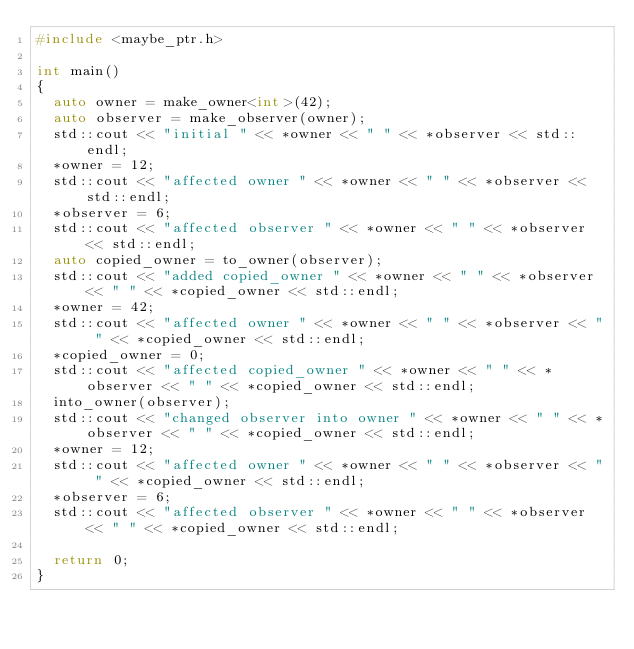Convert code to text. <code><loc_0><loc_0><loc_500><loc_500><_C++_>#include <maybe_ptr.h>

int main()
{
  auto owner = make_owner<int>(42);
  auto observer = make_observer(owner);
  std::cout << "initial " << *owner << " " << *observer << std::endl;
  *owner = 12;
  std::cout << "affected owner " << *owner << " " << *observer << std::endl;
  *observer = 6;
  std::cout << "affected observer " << *owner << " " << *observer << std::endl;
  auto copied_owner = to_owner(observer);
  std::cout << "added copied_owner " << *owner << " " << *observer << " " << *copied_owner << std::endl;
  *owner = 42;
  std::cout << "affected owner " << *owner << " " << *observer << " " << *copied_owner << std::endl;
  *copied_owner = 0;
  std::cout << "affected copied_owner " << *owner << " " << *observer << " " << *copied_owner << std::endl;
  into_owner(observer);
  std::cout << "changed observer into owner " << *owner << " " << *observer << " " << *copied_owner << std::endl;
  *owner = 12;
  std::cout << "affected owner " << *owner << " " << *observer << " " << *copied_owner << std::endl;
  *observer = 6;
  std::cout << "affected observer " << *owner << " " << *observer << " " << *copied_owner << std::endl;

  return 0;
}
</code> 